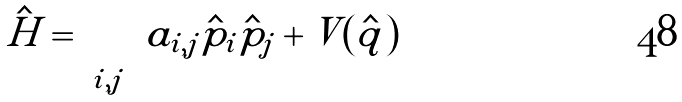<formula> <loc_0><loc_0><loc_500><loc_500>\hat { H } = \sum _ { i , j } a _ { i , j } \hat { p } _ { i } \hat { p } _ { j } + V ( \hat { q } )</formula> 